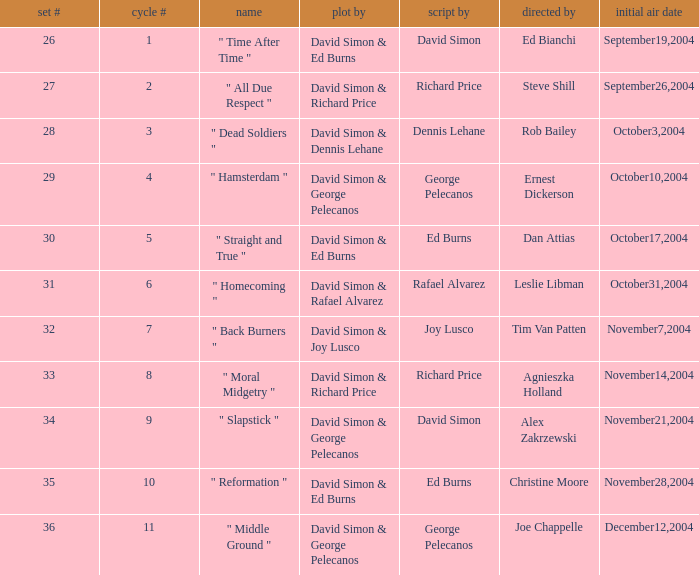What is the season # for a teleplay by Richard Price and the director is Steve Shill? 2.0. 